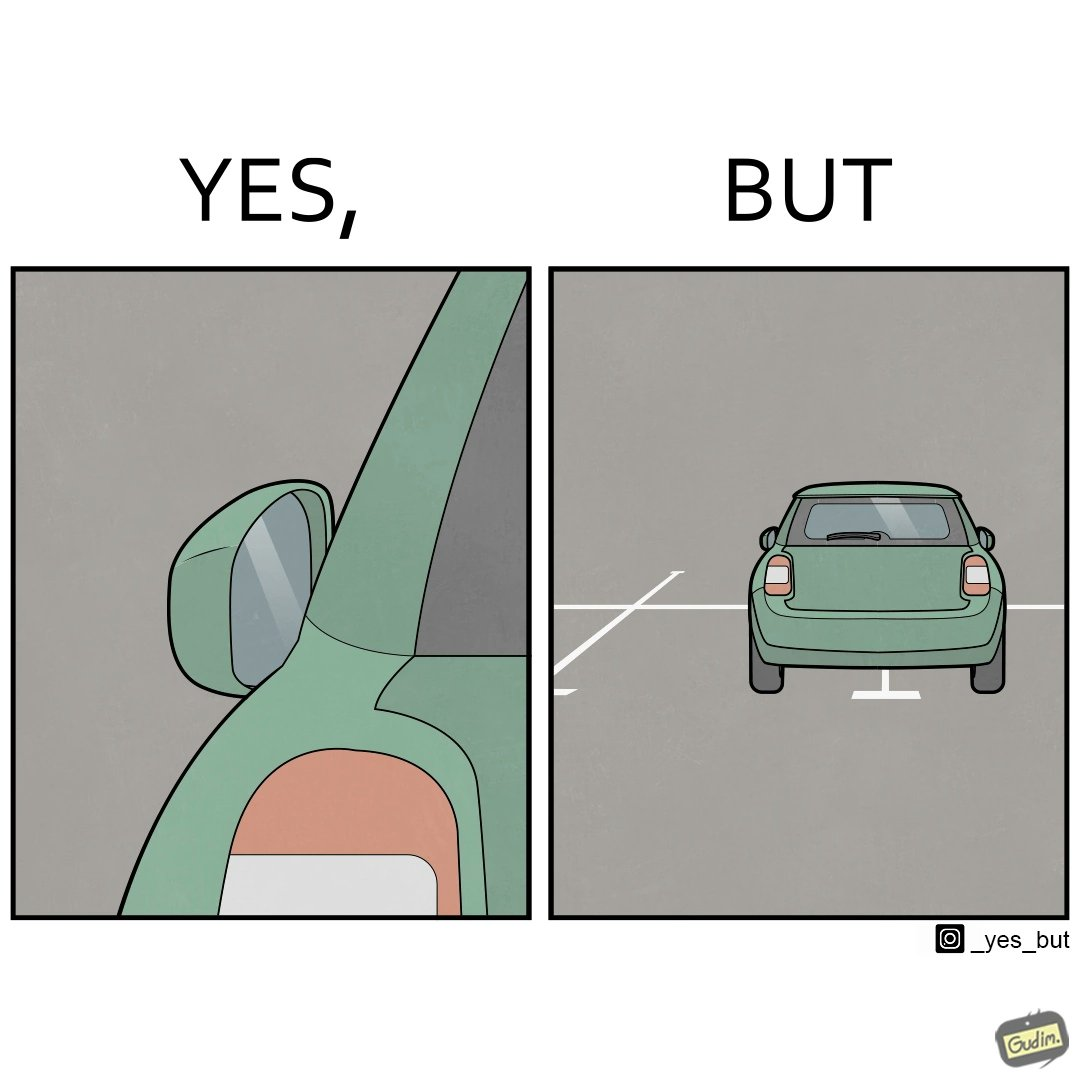Would you classify this image as satirical? Yes, this image is satirical. 